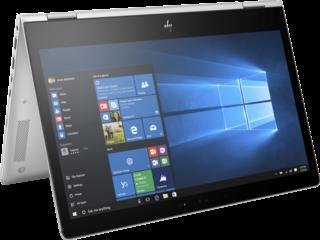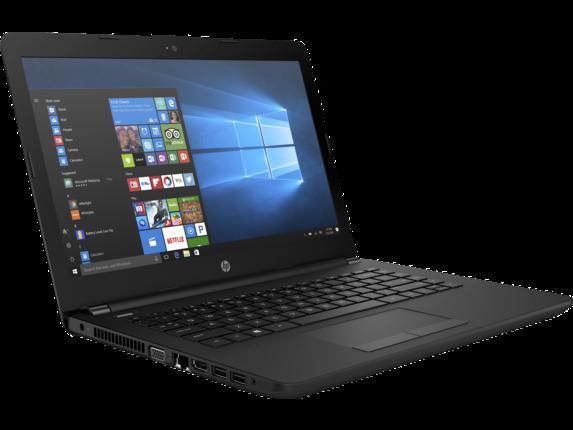The first image is the image on the left, the second image is the image on the right. Assess this claim about the two images: "At least one laptop is pictured against a black background.". Correct or not? Answer yes or no. Yes. 